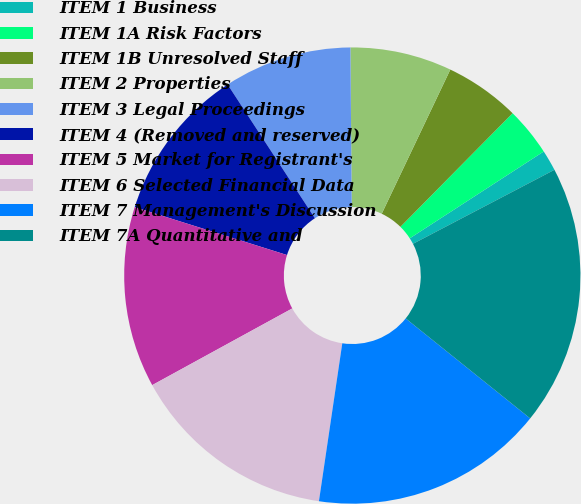Convert chart. <chart><loc_0><loc_0><loc_500><loc_500><pie_chart><fcel>ITEM 1 Business<fcel>ITEM 1A Risk Factors<fcel>ITEM 1B Unresolved Staff<fcel>ITEM 2 Properties<fcel>ITEM 3 Legal Proceedings<fcel>ITEM 4 (Removed and reserved)<fcel>ITEM 5 Market for Registrant's<fcel>ITEM 6 Selected Financial Data<fcel>ITEM 7 Management's Discussion<fcel>ITEM 7A Quantitative and<nl><fcel>1.48%<fcel>3.45%<fcel>5.33%<fcel>7.2%<fcel>9.07%<fcel>10.95%<fcel>12.82%<fcel>14.69%<fcel>16.57%<fcel>18.44%<nl></chart> 